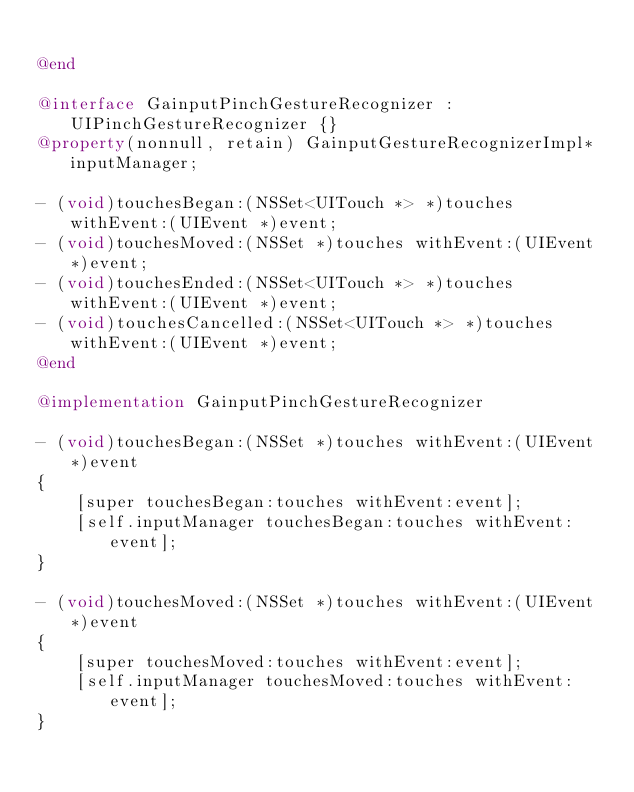Convert code to text. <code><loc_0><loc_0><loc_500><loc_500><_ObjectiveC_>
@end

@interface GainputPinchGestureRecognizer : UIPinchGestureRecognizer {}
@property(nonnull, retain) GainputGestureRecognizerImpl* inputManager;

- (void)touchesBegan:(NSSet<UITouch *> *)touches withEvent:(UIEvent *)event;
- (void)touchesMoved:(NSSet *)touches withEvent:(UIEvent *)event;
- (void)touchesEnded:(NSSet<UITouch *> *)touches withEvent:(UIEvent *)event;
- (void)touchesCancelled:(NSSet<UITouch *> *)touches withEvent:(UIEvent *)event;
@end

@implementation GainputPinchGestureRecognizer

- (void)touchesBegan:(NSSet *)touches withEvent:(UIEvent *)event
{
	[super touchesBegan:touches withEvent:event];
	[self.inputManager touchesBegan:touches withEvent:event];
}

- (void)touchesMoved:(NSSet *)touches withEvent:(UIEvent *)event
{
	[super touchesMoved:touches withEvent:event];
	[self.inputManager touchesMoved:touches withEvent:event];
}
</code> 